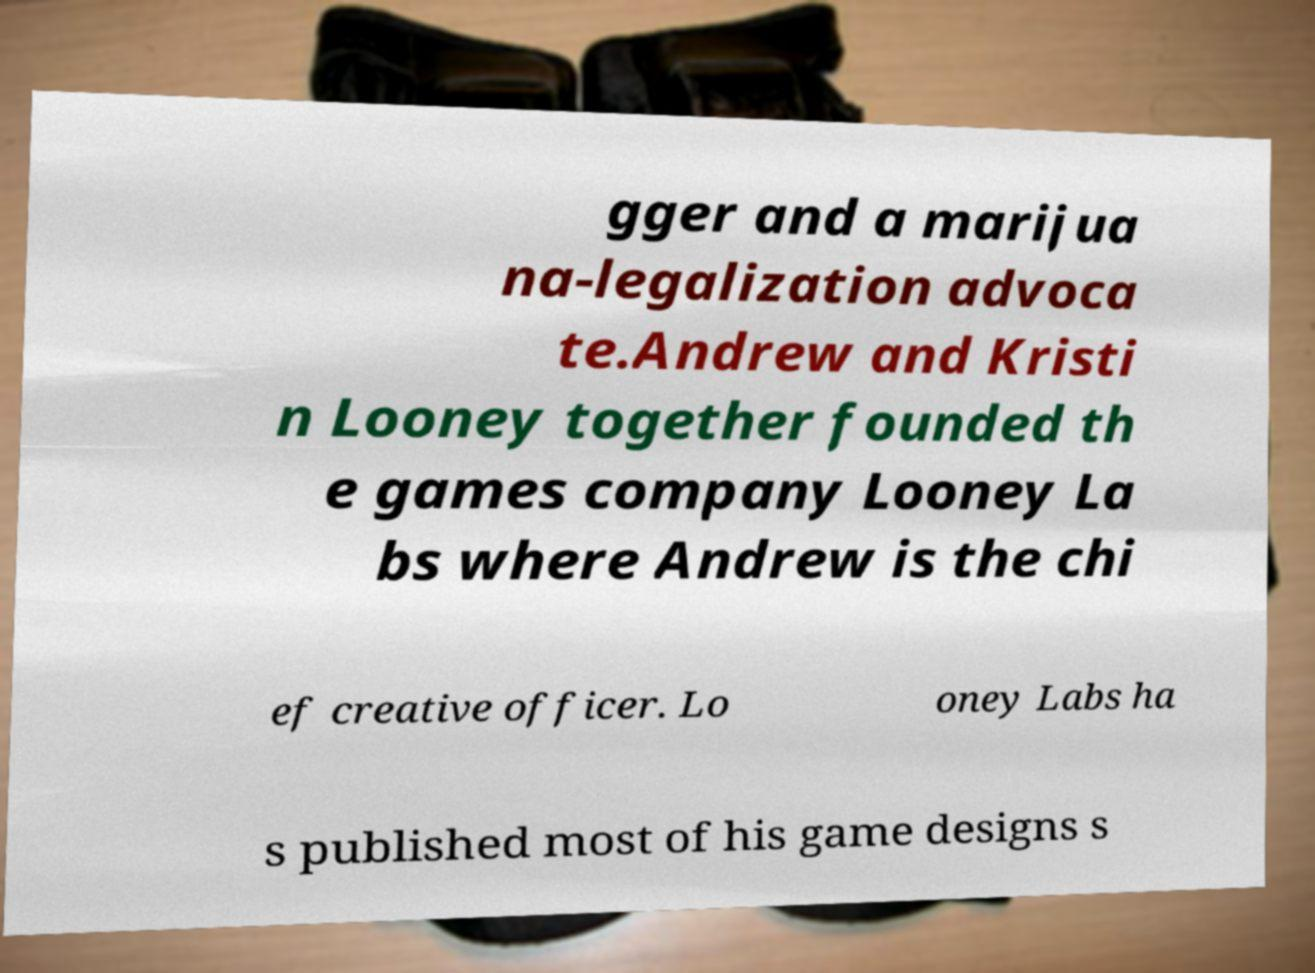Can you accurately transcribe the text from the provided image for me? gger and a marijua na-legalization advoca te.Andrew and Kristi n Looney together founded th e games company Looney La bs where Andrew is the chi ef creative officer. Lo oney Labs ha s published most of his game designs s 